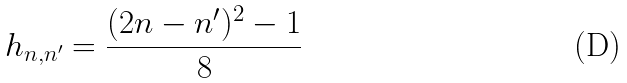<formula> <loc_0><loc_0><loc_500><loc_500>h _ { n , n ^ { \prime } } = \frac { ( 2 n - n ^ { \prime } ) ^ { 2 } - 1 } { 8 }</formula> 